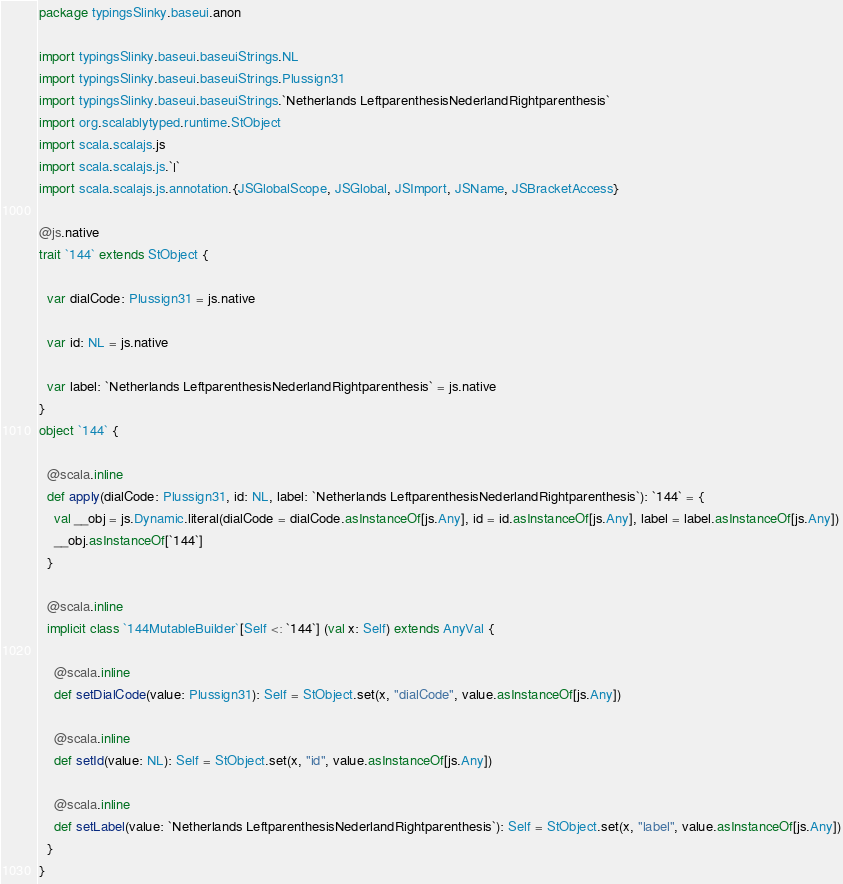<code> <loc_0><loc_0><loc_500><loc_500><_Scala_>package typingsSlinky.baseui.anon

import typingsSlinky.baseui.baseuiStrings.NL
import typingsSlinky.baseui.baseuiStrings.Plussign31
import typingsSlinky.baseui.baseuiStrings.`Netherlands LeftparenthesisNederlandRightparenthesis`
import org.scalablytyped.runtime.StObject
import scala.scalajs.js
import scala.scalajs.js.`|`
import scala.scalajs.js.annotation.{JSGlobalScope, JSGlobal, JSImport, JSName, JSBracketAccess}

@js.native
trait `144` extends StObject {
  
  var dialCode: Plussign31 = js.native
  
  var id: NL = js.native
  
  var label: `Netherlands LeftparenthesisNederlandRightparenthesis` = js.native
}
object `144` {
  
  @scala.inline
  def apply(dialCode: Plussign31, id: NL, label: `Netherlands LeftparenthesisNederlandRightparenthesis`): `144` = {
    val __obj = js.Dynamic.literal(dialCode = dialCode.asInstanceOf[js.Any], id = id.asInstanceOf[js.Any], label = label.asInstanceOf[js.Any])
    __obj.asInstanceOf[`144`]
  }
  
  @scala.inline
  implicit class `144MutableBuilder`[Self <: `144`] (val x: Self) extends AnyVal {
    
    @scala.inline
    def setDialCode(value: Plussign31): Self = StObject.set(x, "dialCode", value.asInstanceOf[js.Any])
    
    @scala.inline
    def setId(value: NL): Self = StObject.set(x, "id", value.asInstanceOf[js.Any])
    
    @scala.inline
    def setLabel(value: `Netherlands LeftparenthesisNederlandRightparenthesis`): Self = StObject.set(x, "label", value.asInstanceOf[js.Any])
  }
}
</code> 